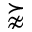<formula> <loc_0><loc_0><loc_500><loc_500>\succnapprox</formula> 